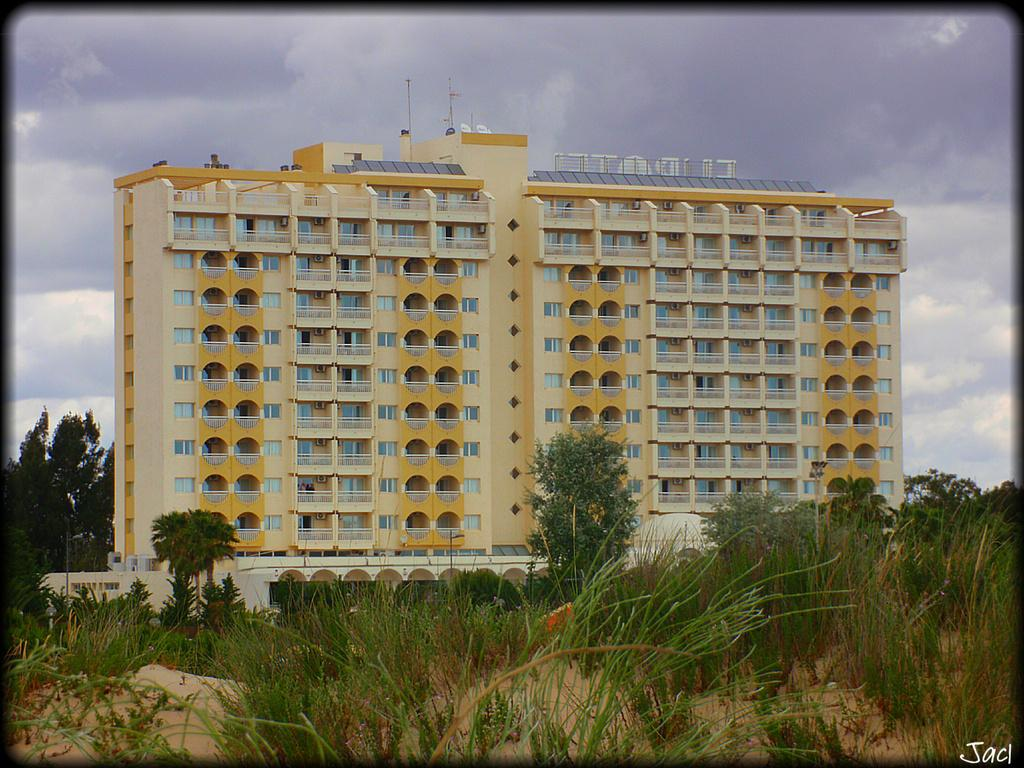What type of structure is in the image? There is a building in the image. What can be seen in front of the building? Trees, plants, and grass are visible in front of the building. What is visible at the top of the image? The sky is visible at the top of the image. What is the profit margin of the engine in the image? There is no engine or mention of profit in the image; it features a building with trees, plants, grass, and the sky. 